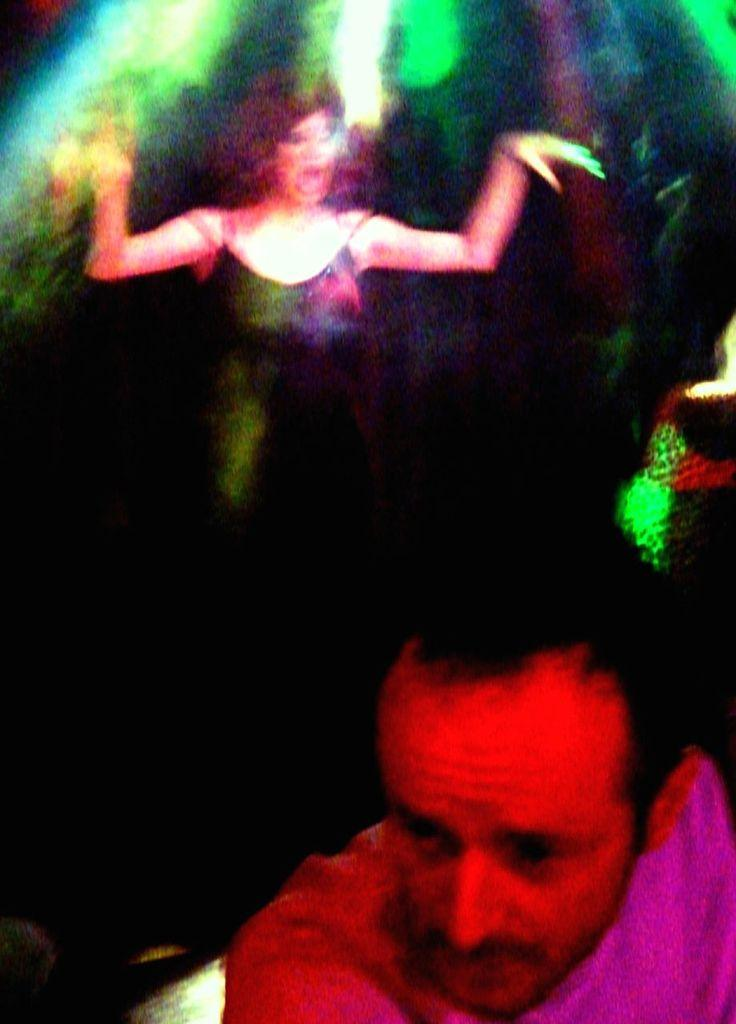Where was the image taken? The image was taken indoors. Can you describe the background of the image? The background is a little blurred. Are there any light sources visible in the image? Yes, there are a few lights in the image. Who can be seen in the image? There is a woman and a man in the image. How many girls are present in the image? There are no girls present in the image; it features a woman and a man. What is the temper of the pocket in the image? There is no pocket present in the image, and therefore no temper can be attributed to it. 